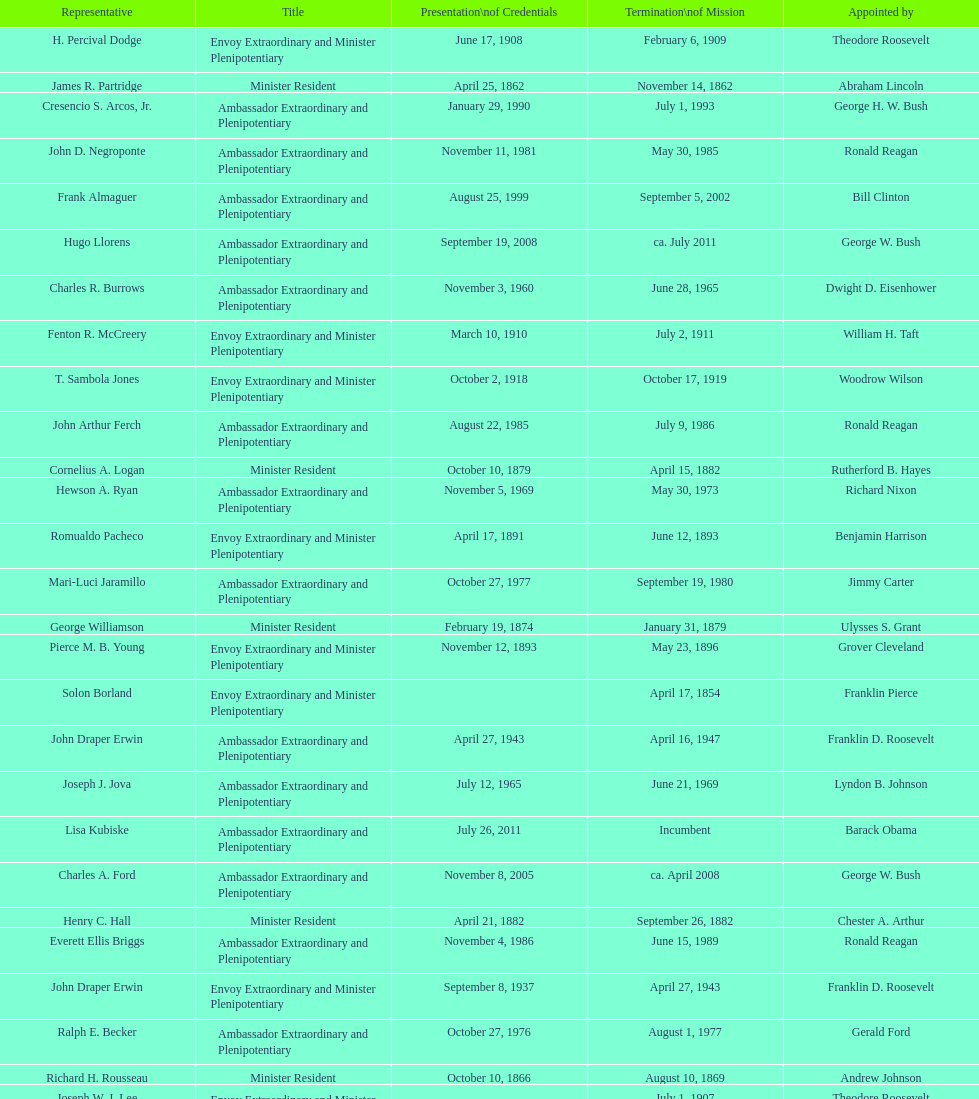Which reps were only appointed by franklin pierce? Solon Borland. 